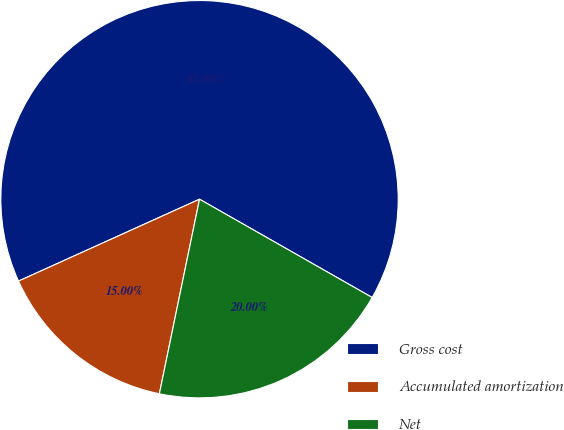<chart> <loc_0><loc_0><loc_500><loc_500><pie_chart><fcel>Gross cost<fcel>Accumulated amortization<fcel>Net<nl><fcel>65.0%<fcel>15.0%<fcel>20.0%<nl></chart> 